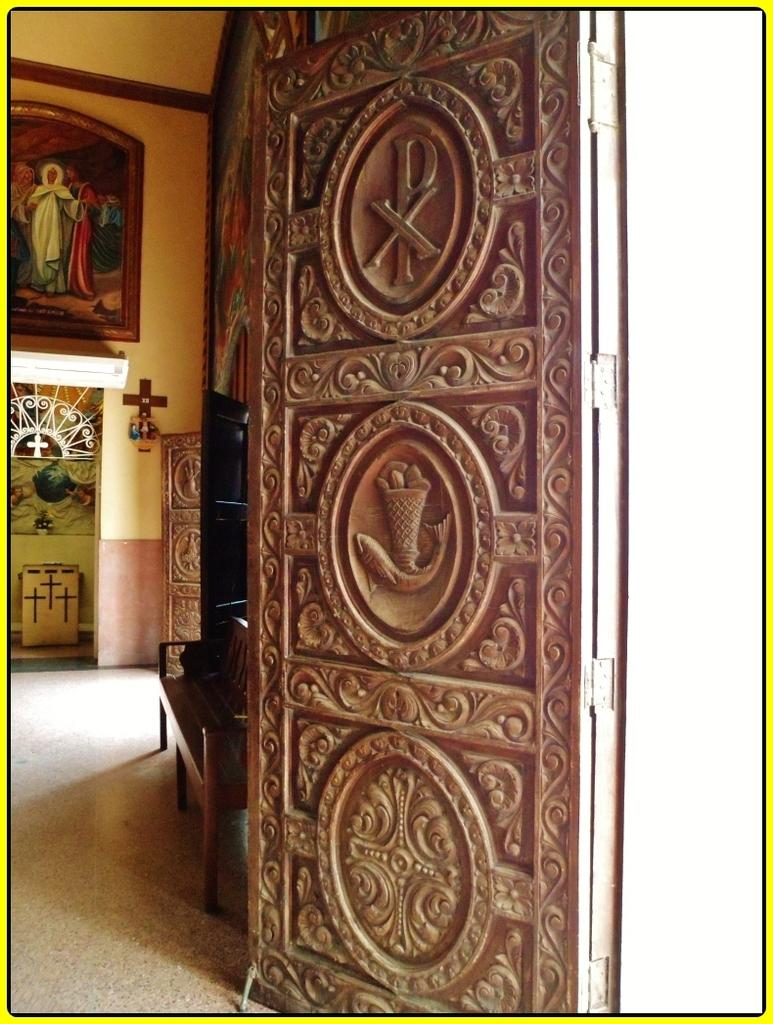What is located at the front of the image? There is a door in the front of the image. What can be seen in the background of the image? There is an empty bench in the background of the image. What is on the wall in the image? There is a frame on the wall in the image. What type of powder can be seen covering the frame in the image? There is no powder present on the frame in the image. How many pizzas are visible on the bench in the image? There are no pizzas present on the bench in the image. 